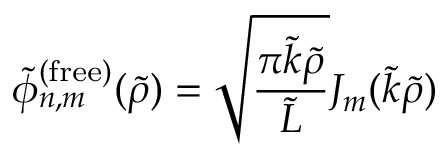Convert formula to latex. <formula><loc_0><loc_0><loc_500><loc_500>\tilde { \phi } _ { n , m } ^ { ( f r e e ) } ( \tilde { \rho } ) = \sqrt { \frac { \pi \tilde { k } \tilde { \rho } } { \tilde { L } } } J _ { m } ( \tilde { k } \tilde { \rho } )</formula> 